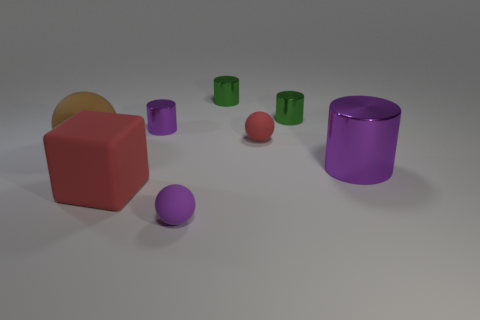If we were to categorize the objects by texture, how would we group them? In terms of texture, the objects can be grouped into two categories. The larger shapes, such as the big red cube and the big purple cylinder, appear to have a smooth, perhaps even slightly shiny surface. In contrast, the small red sphere behind the purple cylinder gives off a matte appearance, with no reflections visible, implying a non-glossy texture. These textural differences add depth and interest to the visual experience.  Imagine if this were a scene from a story, what might be happening? If this were a scene from a story, one might imagine it as a moment captured in a magical workshop where enchanted objects have been left scattered about by a whimsical inventor. Each object could possess its own unique ability or story, like the large red cube being a powerful puzzle box and the big purple cylinder a portal to another dimension. The scene waits quietly for the return of the creator, ready to spring to life with a touch of magic. 